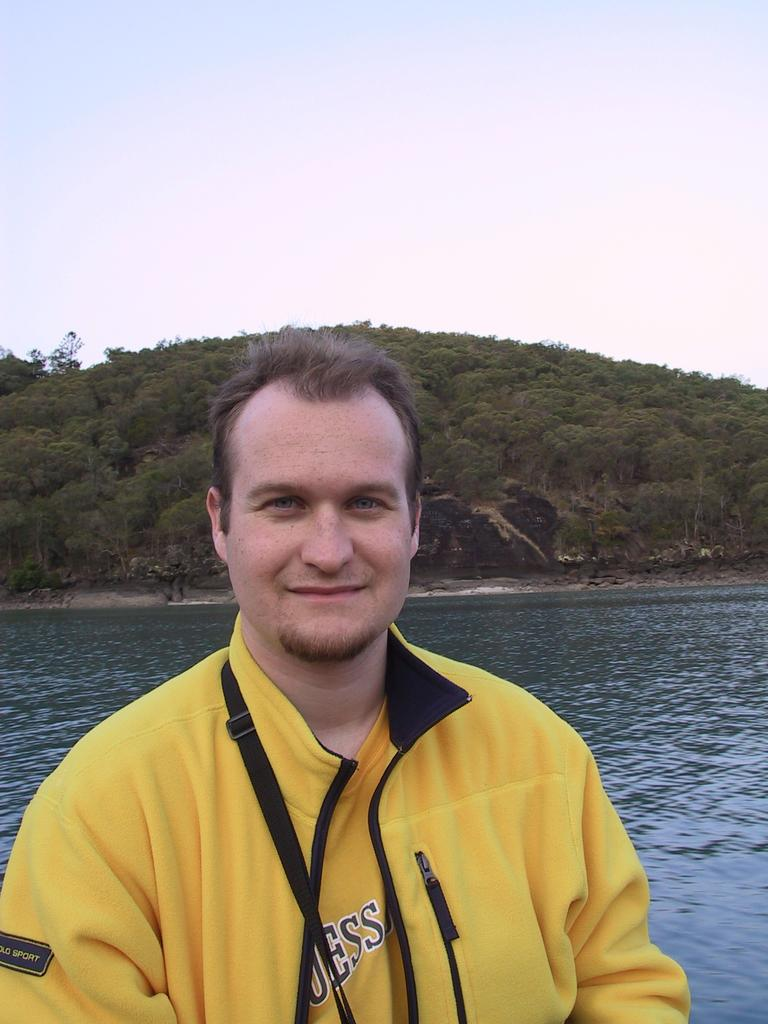<image>
Present a compact description of the photo's key features. A man standing in front of water wearing a Polo Sport jacket. 